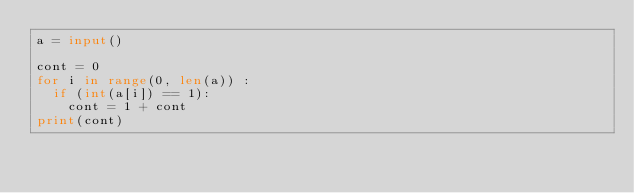Convert code to text. <code><loc_0><loc_0><loc_500><loc_500><_Python_>a = input()

cont = 0
for i in range(0, len(a)) :
  if (int(a[i]) == 1):
    cont = 1 + cont
print(cont)</code> 